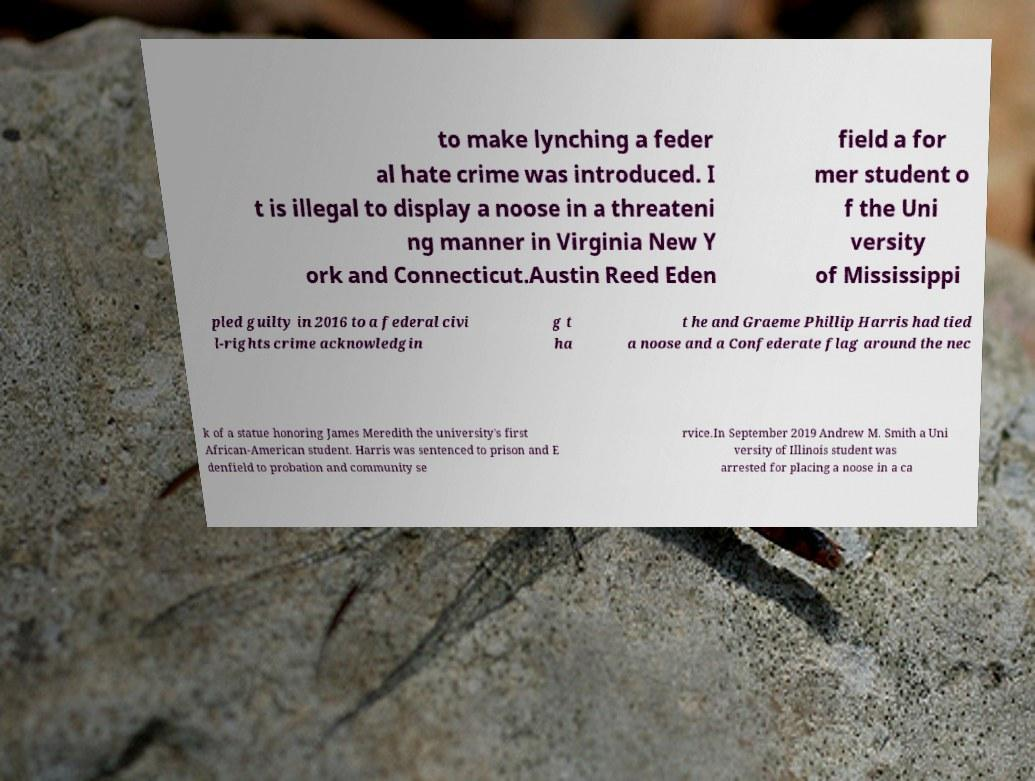Can you read and provide the text displayed in the image?This photo seems to have some interesting text. Can you extract and type it out for me? to make lynching a feder al hate crime was introduced. I t is illegal to display a noose in a threateni ng manner in Virginia New Y ork and Connecticut.Austin Reed Eden field a for mer student o f the Uni versity of Mississippi pled guilty in 2016 to a federal civi l-rights crime acknowledgin g t ha t he and Graeme Phillip Harris had tied a noose and a Confederate flag around the nec k of a statue honoring James Meredith the university's first African-American student. Harris was sentenced to prison and E denfield to probation and community se rvice.In September 2019 Andrew M. Smith a Uni versity of Illinois student was arrested for placing a noose in a ca 